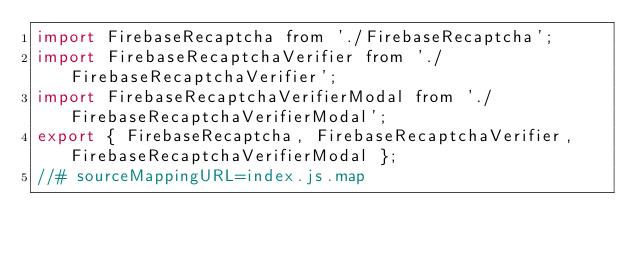Convert code to text. <code><loc_0><loc_0><loc_500><loc_500><_JavaScript_>import FirebaseRecaptcha from './FirebaseRecaptcha';
import FirebaseRecaptchaVerifier from './FirebaseRecaptchaVerifier';
import FirebaseRecaptchaVerifierModal from './FirebaseRecaptchaVerifierModal';
export { FirebaseRecaptcha, FirebaseRecaptchaVerifier, FirebaseRecaptchaVerifierModal };
//# sourceMappingURL=index.js.map</code> 